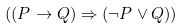<formula> <loc_0><loc_0><loc_500><loc_500>( ( P \rightarrow Q ) \Rightarrow ( \neg P \vee Q ) )</formula> 